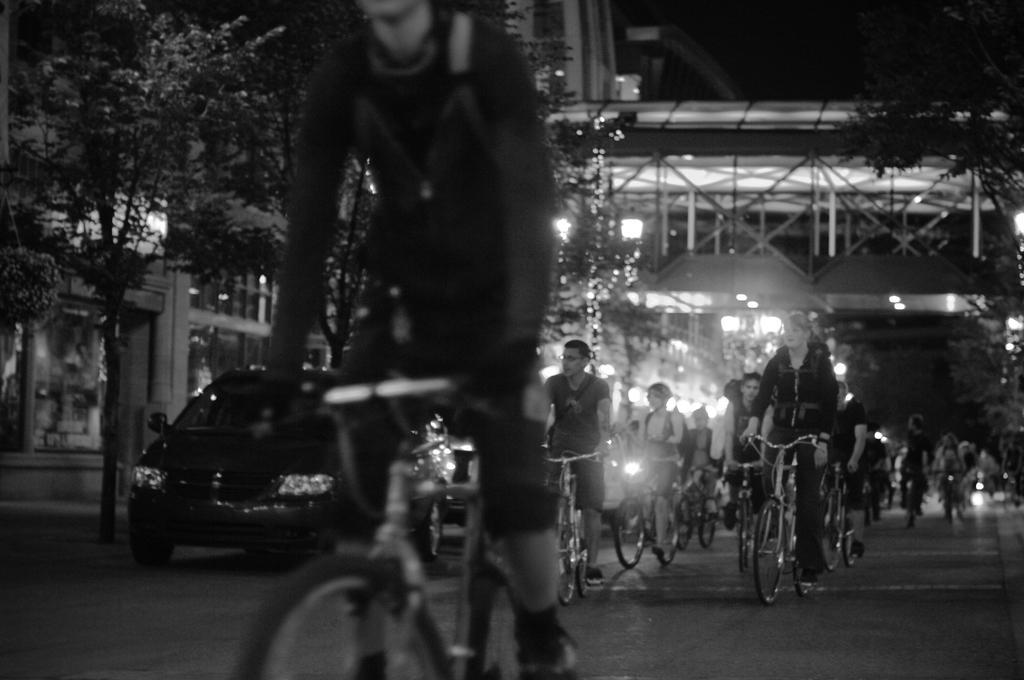Could you give a brief overview of what you see in this image? There are so many people riding a bicycle under the bridge behind them there is a building and a car parked under the trees. 